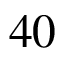<formula> <loc_0><loc_0><loc_500><loc_500>4 0</formula> 